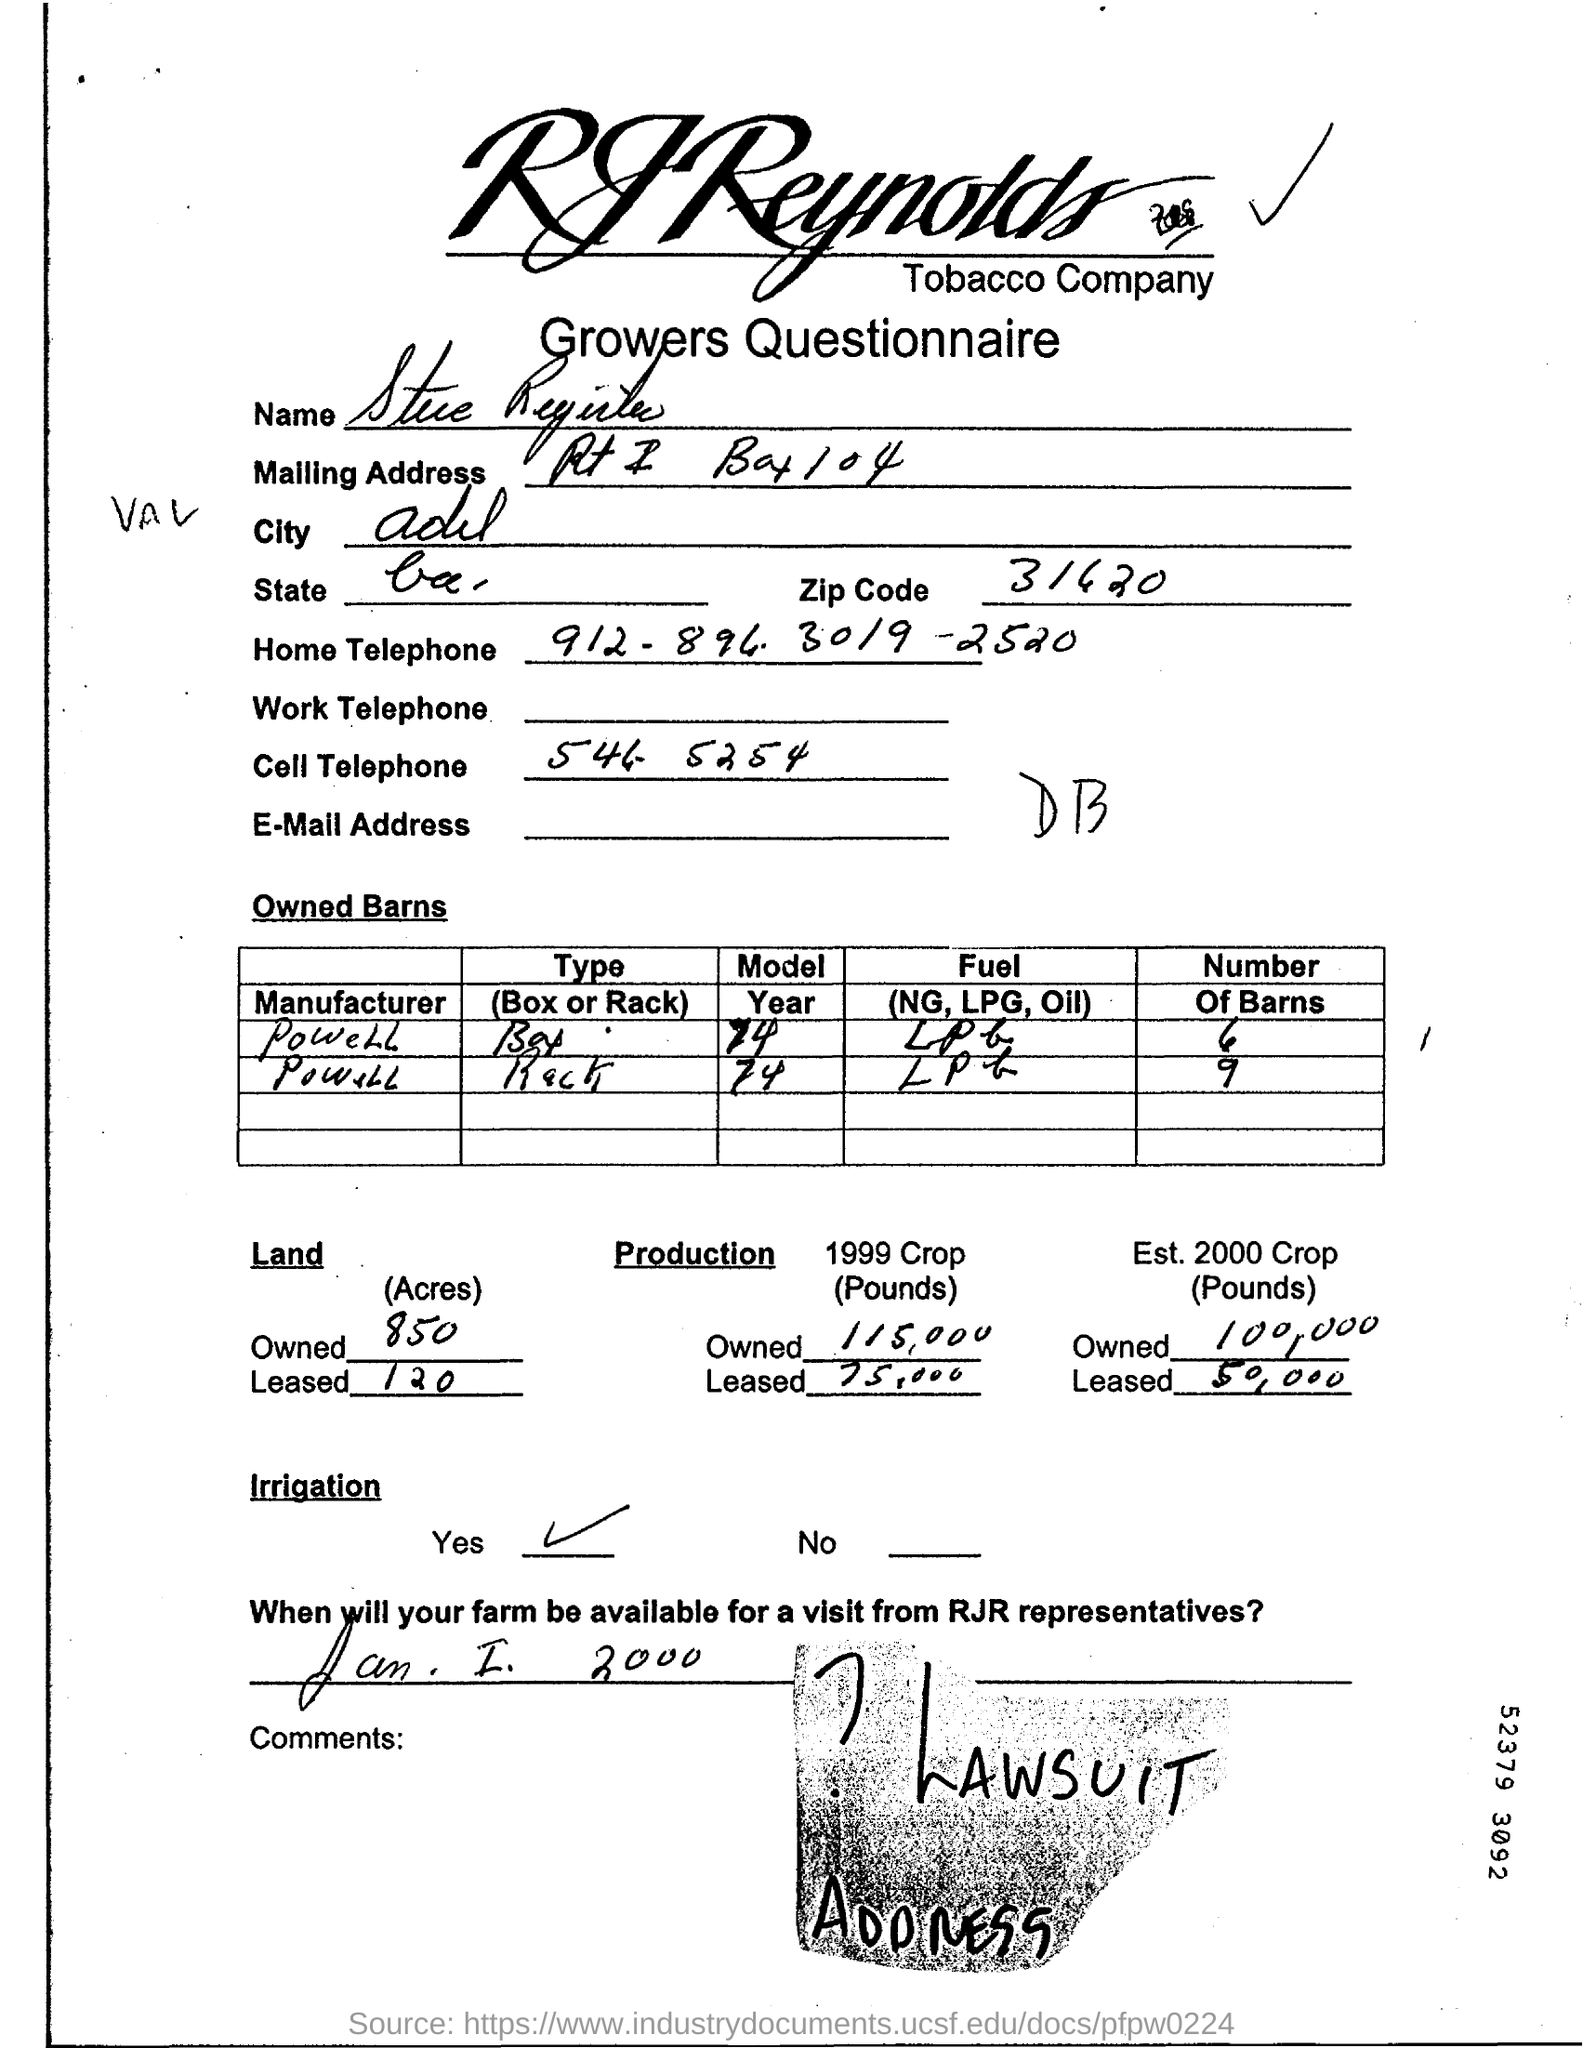Specify some key components in this picture. The zip code is 31620. 